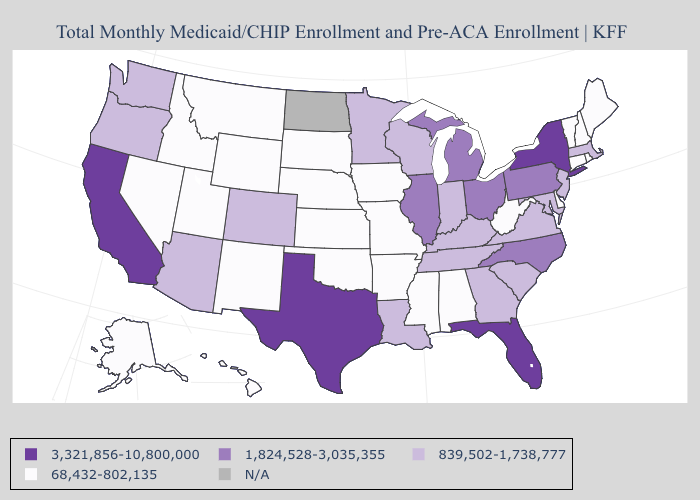What is the value of South Dakota?
Give a very brief answer. 68,432-802,135. Among the states that border Tennessee , which have the lowest value?
Short answer required. Alabama, Arkansas, Mississippi, Missouri. Among the states that border Tennessee , does Arkansas have the highest value?
Quick response, please. No. Is the legend a continuous bar?
Write a very short answer. No. Name the states that have a value in the range 839,502-1,738,777?
Concise answer only. Arizona, Colorado, Georgia, Indiana, Kentucky, Louisiana, Maryland, Massachusetts, Minnesota, New Jersey, Oregon, South Carolina, Tennessee, Virginia, Washington, Wisconsin. Does Washington have the lowest value in the West?
Answer briefly. No. How many symbols are there in the legend?
Write a very short answer. 5. What is the value of Vermont?
Short answer required. 68,432-802,135. Which states have the lowest value in the South?
Keep it brief. Alabama, Arkansas, Delaware, Mississippi, Oklahoma, West Virginia. Name the states that have a value in the range 68,432-802,135?
Give a very brief answer. Alabama, Alaska, Arkansas, Connecticut, Delaware, Hawaii, Idaho, Iowa, Kansas, Maine, Mississippi, Missouri, Montana, Nebraska, Nevada, New Hampshire, New Mexico, Oklahoma, Rhode Island, South Dakota, Utah, Vermont, West Virginia, Wyoming. What is the value of South Dakota?
Give a very brief answer. 68,432-802,135. What is the value of Vermont?
Keep it brief. 68,432-802,135. Name the states that have a value in the range 1,824,528-3,035,355?
Concise answer only. Illinois, Michigan, North Carolina, Ohio, Pennsylvania. What is the highest value in states that border Tennessee?
Give a very brief answer. 1,824,528-3,035,355. 